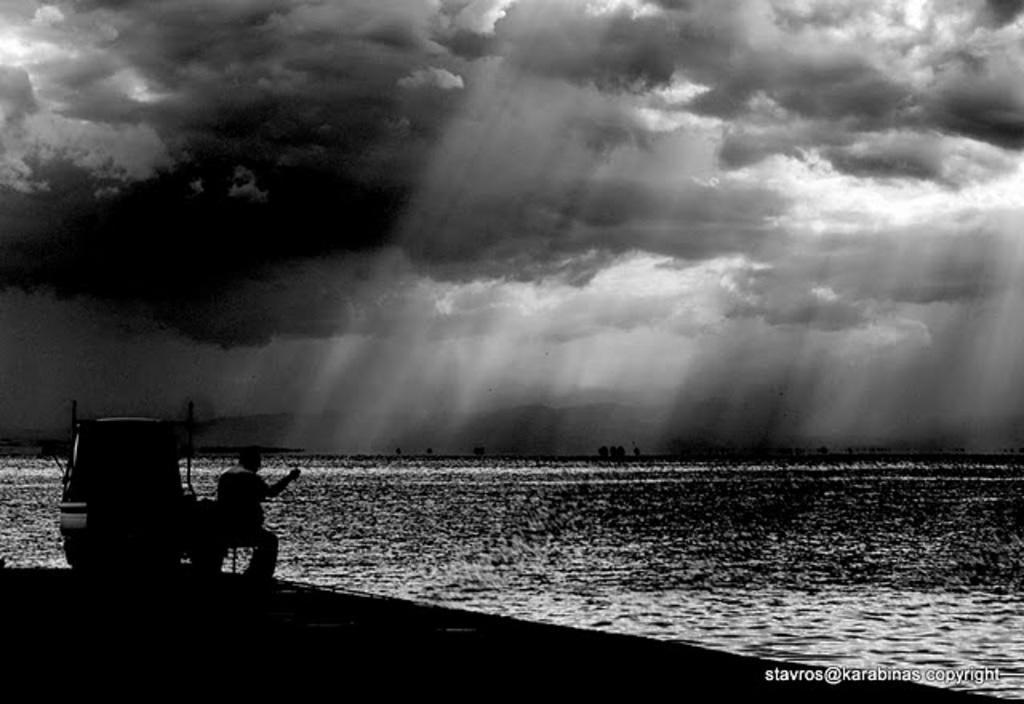Could you give a brief overview of what you see in this image? This is a black and white image. We can see a person sitting. On the left side of the person, it looks like a vehicle. In front of the person, there are hills and the sea. At the top of the image, there is the cloudy sky. In the bottom right corner of the image, there is a watermark. 